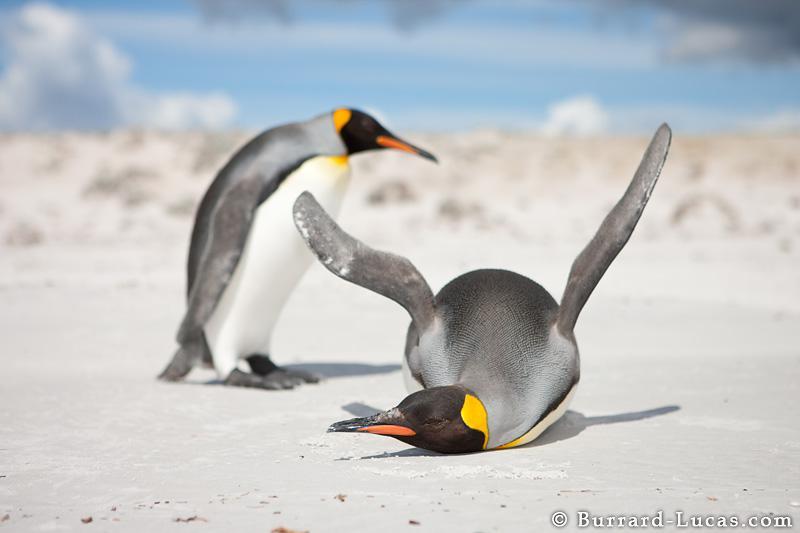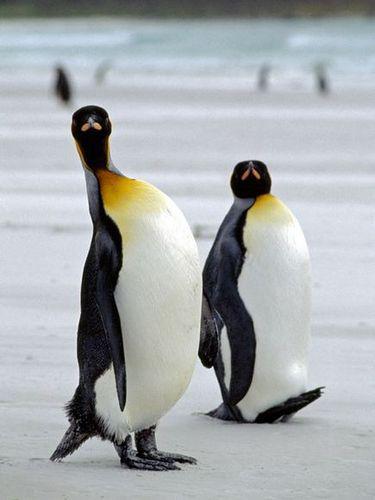The first image is the image on the left, the second image is the image on the right. Evaluate the accuracy of this statement regarding the images: "2 penguins are facing each other with chests almost touching". Is it true? Answer yes or no. No. The first image is the image on the left, the second image is the image on the right. Considering the images on both sides, is "There are exactly three penguins." valid? Answer yes or no. No. 